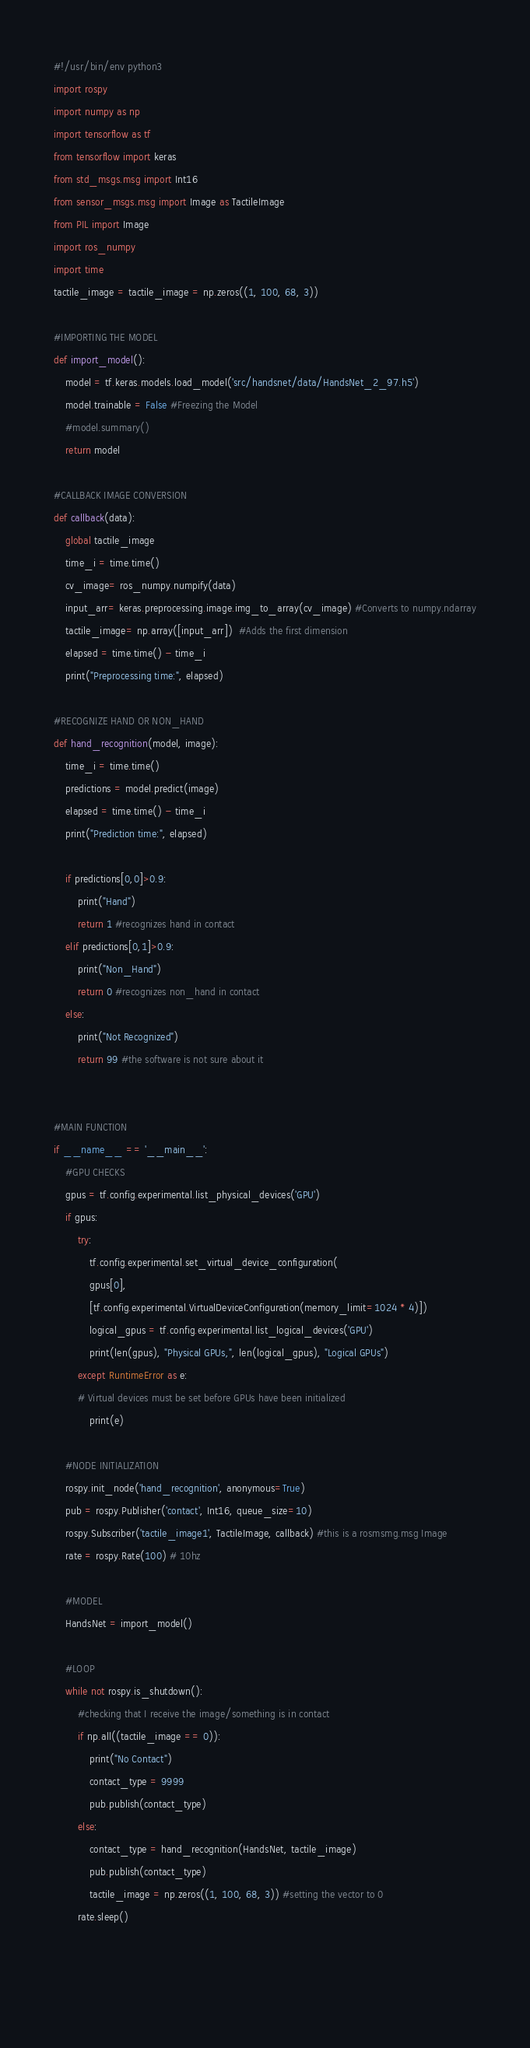Convert code to text. <code><loc_0><loc_0><loc_500><loc_500><_Python_>#!/usr/bin/env python3
import rospy
import numpy as np
import tensorflow as tf
from tensorflow import keras
from std_msgs.msg import Int16
from sensor_msgs.msg import Image as TactileImage
from PIL import Image
import ros_numpy
import time
tactile_image = tactile_image = np.zeros((1, 100, 68, 3))

#IMPORTING THE MODEL
def import_model():
    model = tf.keras.models.load_model('src/handsnet/data/HandsNet_2_97.h5')
    model.trainable = False #Freezing the Model
    #model.summary()
    return model

#CALLBACK IMAGE CONVERSION
def callback(data):
    global tactile_image 
    time_i = time.time()
    cv_image= ros_numpy.numpify(data)
    input_arr= keras.preprocessing.image.img_to_array(cv_image) #Converts to numpy.ndarray
    tactile_image= np.array([input_arr])  #Adds the first dimension
    elapsed = time.time() - time_i
    print("Preprocessing time:", elapsed)

#RECOGNIZE HAND OR NON_HAND
def hand_recognition(model, image): 
    time_i = time.time()
    predictions = model.predict(image)
    elapsed = time.time() - time_i
    print("Prediction time:", elapsed)

    if predictions[0,0]>0.9:
        print("Hand")
        return 1 #recognizes hand in contact
    elif predictions[0,1]>0.9:
        print("Non_Hand")
        return 0 #recognizes non_hand in contact
    else: 
        print("Not Recognized")
        return 99 #the software is not sure about it   


#MAIN FUNCTION
if __name__ == '__main__':
    #GPU CHECKS
    gpus = tf.config.experimental.list_physical_devices('GPU')
    if gpus:
        try:
            tf.config.experimental.set_virtual_device_configuration(
            gpus[0],
            [tf.config.experimental.VirtualDeviceConfiguration(memory_limit=1024 * 4)])
            logical_gpus = tf.config.experimental.list_logical_devices('GPU')
            print(len(gpus), "Physical GPUs,", len(logical_gpus), "Logical GPUs")
        except RuntimeError as e:
        # Virtual devices must be set before GPUs have been initialized
            print(e)

    #NODE INITIALIZATION
    rospy.init_node('hand_recognition', anonymous=True)
    pub = rospy.Publisher('contact', Int16, queue_size=10)
    rospy.Subscriber('tactile_image1', TactileImage, callback) #this is a rosmsmg.msg Image
    rate = rospy.Rate(100) # 10hz

    #MODEL
    HandsNet = import_model()
    
    #LOOP
    while not rospy.is_shutdown():
        #checking that I receive the image/something is in contact
        if np.all((tactile_image == 0)):
            print("No Contact")
            contact_type = 9999
            pub.publish(contact_type)
        else:
            contact_type = hand_recognition(HandsNet, tactile_image)
            pub.publish(contact_type)
            tactile_image = np.zeros((1, 100, 68, 3)) #setting the vector to 0
        rate.sleep()


    

</code> 